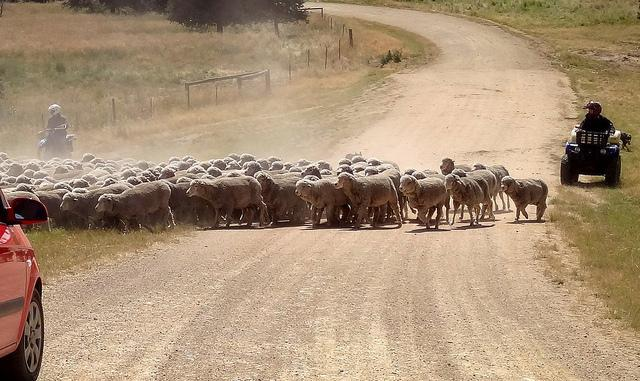Why are the sheep turning right? Please explain your reasoning. avoiding car. The sheep are crossing the street. 